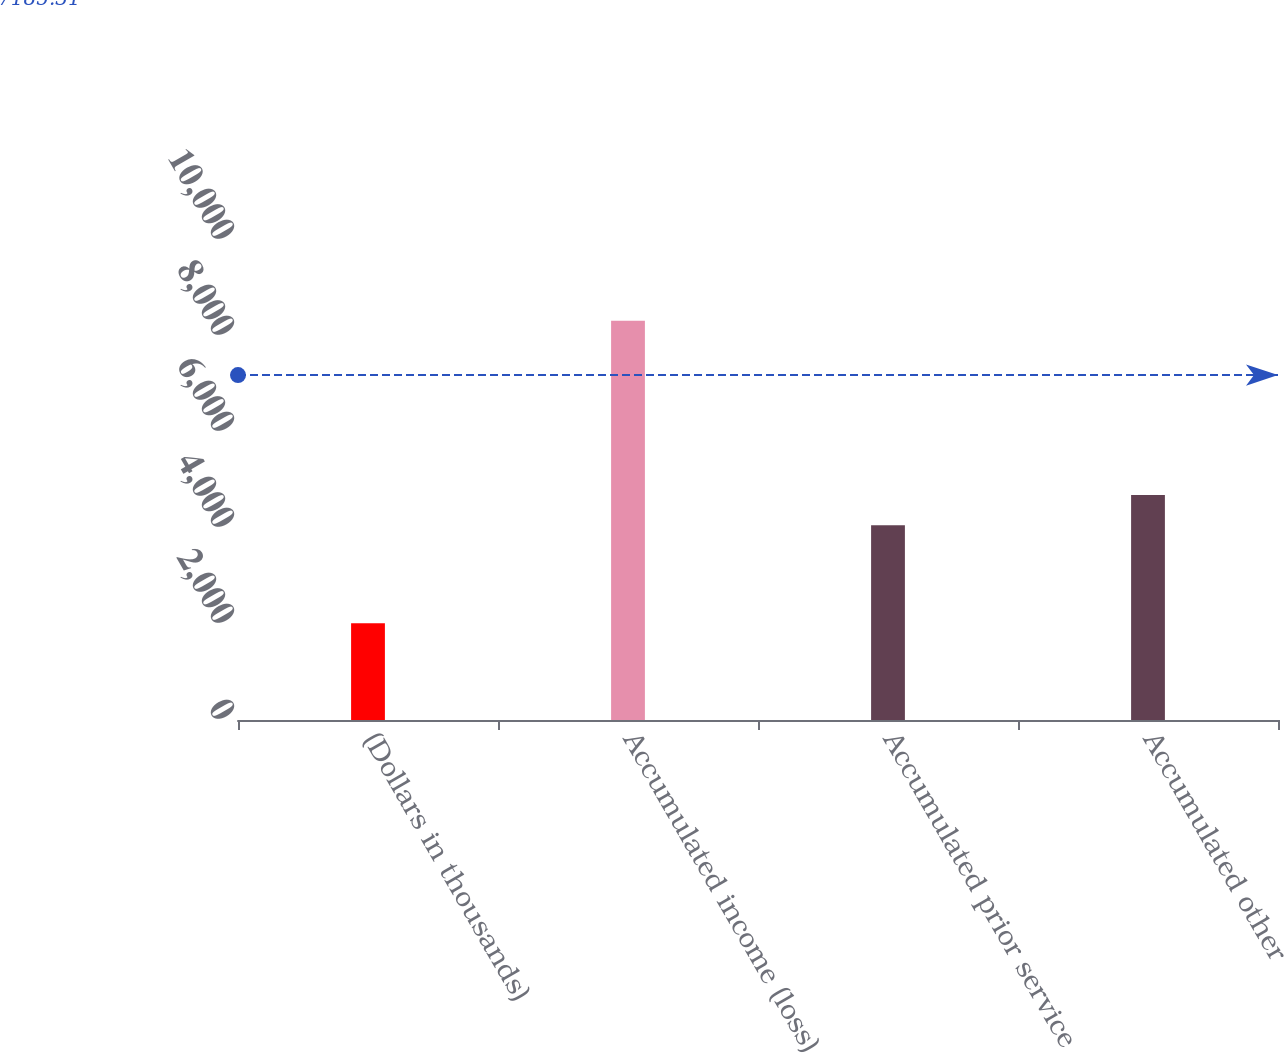Convert chart to OTSL. <chart><loc_0><loc_0><loc_500><loc_500><bar_chart><fcel>(Dollars in thousands)<fcel>Accumulated income (loss)<fcel>Accumulated prior service<fcel>Accumulated other<nl><fcel>2017<fcel>8317<fcel>4057<fcel>4687<nl></chart> 